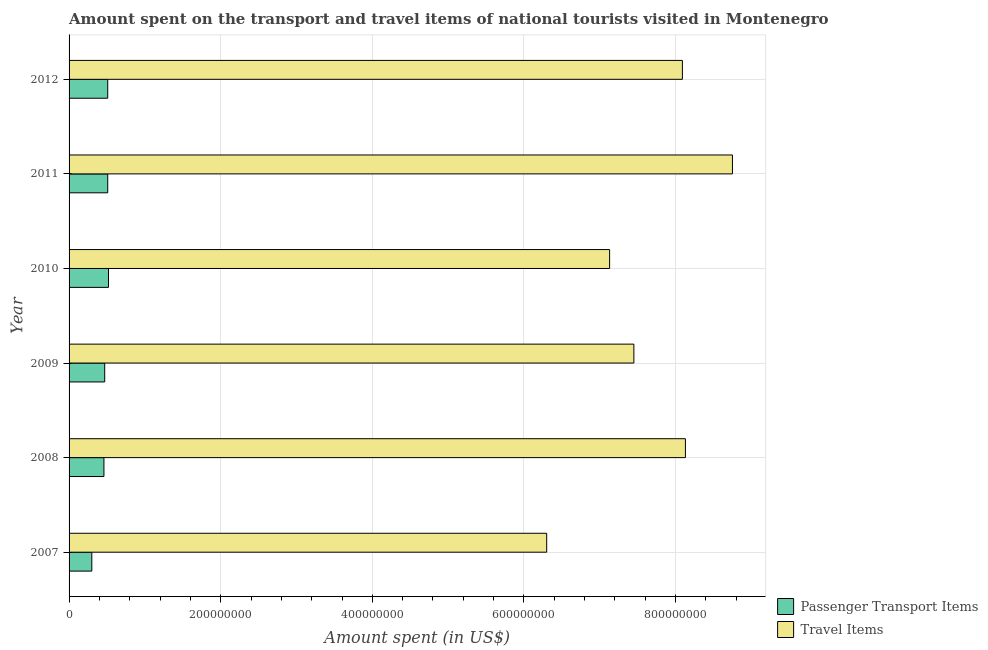How many different coloured bars are there?
Offer a very short reply. 2. How many groups of bars are there?
Keep it short and to the point. 6. What is the label of the 2nd group of bars from the top?
Your response must be concise. 2011. What is the amount spent on passenger transport items in 2007?
Offer a very short reply. 3.00e+07. Across all years, what is the maximum amount spent in travel items?
Provide a short and direct response. 8.75e+08. Across all years, what is the minimum amount spent on passenger transport items?
Your answer should be very brief. 3.00e+07. What is the total amount spent in travel items in the graph?
Your response must be concise. 4.58e+09. What is the difference between the amount spent on passenger transport items in 2007 and that in 2010?
Your answer should be compact. -2.20e+07. What is the difference between the amount spent on passenger transport items in 2009 and the amount spent in travel items in 2007?
Provide a succinct answer. -5.83e+08. What is the average amount spent in travel items per year?
Ensure brevity in your answer.  7.64e+08. In the year 2011, what is the difference between the amount spent on passenger transport items and amount spent in travel items?
Keep it short and to the point. -8.24e+08. In how many years, is the amount spent on passenger transport items greater than 760000000 US$?
Keep it short and to the point. 0. What is the ratio of the amount spent in travel items in 2009 to that in 2010?
Ensure brevity in your answer.  1.04. Is the amount spent on passenger transport items in 2007 less than that in 2011?
Make the answer very short. Yes. What is the difference between the highest and the second highest amount spent in travel items?
Offer a terse response. 6.20e+07. What is the difference between the highest and the lowest amount spent on passenger transport items?
Provide a succinct answer. 2.20e+07. Is the sum of the amount spent in travel items in 2008 and 2012 greater than the maximum amount spent on passenger transport items across all years?
Give a very brief answer. Yes. What does the 2nd bar from the top in 2012 represents?
Give a very brief answer. Passenger Transport Items. What does the 1st bar from the bottom in 2008 represents?
Offer a very short reply. Passenger Transport Items. Are all the bars in the graph horizontal?
Provide a succinct answer. Yes. How many years are there in the graph?
Your answer should be very brief. 6. What is the difference between two consecutive major ticks on the X-axis?
Your answer should be compact. 2.00e+08. Are the values on the major ticks of X-axis written in scientific E-notation?
Ensure brevity in your answer.  No. Does the graph contain any zero values?
Make the answer very short. No. Does the graph contain grids?
Offer a very short reply. Yes. Where does the legend appear in the graph?
Your answer should be very brief. Bottom right. How many legend labels are there?
Make the answer very short. 2. How are the legend labels stacked?
Provide a succinct answer. Vertical. What is the title of the graph?
Provide a succinct answer. Amount spent on the transport and travel items of national tourists visited in Montenegro. What is the label or title of the X-axis?
Your response must be concise. Amount spent (in US$). What is the label or title of the Y-axis?
Provide a succinct answer. Year. What is the Amount spent (in US$) in Passenger Transport Items in 2007?
Give a very brief answer. 3.00e+07. What is the Amount spent (in US$) of Travel Items in 2007?
Provide a succinct answer. 6.30e+08. What is the Amount spent (in US$) in Passenger Transport Items in 2008?
Your answer should be compact. 4.60e+07. What is the Amount spent (in US$) in Travel Items in 2008?
Your answer should be very brief. 8.13e+08. What is the Amount spent (in US$) in Passenger Transport Items in 2009?
Keep it short and to the point. 4.70e+07. What is the Amount spent (in US$) of Travel Items in 2009?
Make the answer very short. 7.45e+08. What is the Amount spent (in US$) of Passenger Transport Items in 2010?
Keep it short and to the point. 5.20e+07. What is the Amount spent (in US$) in Travel Items in 2010?
Keep it short and to the point. 7.13e+08. What is the Amount spent (in US$) in Passenger Transport Items in 2011?
Ensure brevity in your answer.  5.10e+07. What is the Amount spent (in US$) in Travel Items in 2011?
Provide a short and direct response. 8.75e+08. What is the Amount spent (in US$) in Passenger Transport Items in 2012?
Provide a short and direct response. 5.10e+07. What is the Amount spent (in US$) of Travel Items in 2012?
Provide a succinct answer. 8.09e+08. Across all years, what is the maximum Amount spent (in US$) in Passenger Transport Items?
Provide a short and direct response. 5.20e+07. Across all years, what is the maximum Amount spent (in US$) in Travel Items?
Provide a short and direct response. 8.75e+08. Across all years, what is the minimum Amount spent (in US$) in Passenger Transport Items?
Your answer should be very brief. 3.00e+07. Across all years, what is the minimum Amount spent (in US$) in Travel Items?
Offer a terse response. 6.30e+08. What is the total Amount spent (in US$) in Passenger Transport Items in the graph?
Offer a terse response. 2.77e+08. What is the total Amount spent (in US$) of Travel Items in the graph?
Make the answer very short. 4.58e+09. What is the difference between the Amount spent (in US$) of Passenger Transport Items in 2007 and that in 2008?
Offer a terse response. -1.60e+07. What is the difference between the Amount spent (in US$) in Travel Items in 2007 and that in 2008?
Provide a short and direct response. -1.83e+08. What is the difference between the Amount spent (in US$) in Passenger Transport Items in 2007 and that in 2009?
Provide a succinct answer. -1.70e+07. What is the difference between the Amount spent (in US$) of Travel Items in 2007 and that in 2009?
Make the answer very short. -1.15e+08. What is the difference between the Amount spent (in US$) in Passenger Transport Items in 2007 and that in 2010?
Ensure brevity in your answer.  -2.20e+07. What is the difference between the Amount spent (in US$) in Travel Items in 2007 and that in 2010?
Offer a very short reply. -8.30e+07. What is the difference between the Amount spent (in US$) in Passenger Transport Items in 2007 and that in 2011?
Make the answer very short. -2.10e+07. What is the difference between the Amount spent (in US$) in Travel Items in 2007 and that in 2011?
Ensure brevity in your answer.  -2.45e+08. What is the difference between the Amount spent (in US$) in Passenger Transport Items in 2007 and that in 2012?
Give a very brief answer. -2.10e+07. What is the difference between the Amount spent (in US$) of Travel Items in 2007 and that in 2012?
Keep it short and to the point. -1.79e+08. What is the difference between the Amount spent (in US$) in Passenger Transport Items in 2008 and that in 2009?
Your answer should be very brief. -1.00e+06. What is the difference between the Amount spent (in US$) of Travel Items in 2008 and that in 2009?
Offer a very short reply. 6.80e+07. What is the difference between the Amount spent (in US$) in Passenger Transport Items in 2008 and that in 2010?
Your answer should be very brief. -6.00e+06. What is the difference between the Amount spent (in US$) of Travel Items in 2008 and that in 2010?
Keep it short and to the point. 1.00e+08. What is the difference between the Amount spent (in US$) of Passenger Transport Items in 2008 and that in 2011?
Ensure brevity in your answer.  -5.00e+06. What is the difference between the Amount spent (in US$) in Travel Items in 2008 and that in 2011?
Make the answer very short. -6.20e+07. What is the difference between the Amount spent (in US$) of Passenger Transport Items in 2008 and that in 2012?
Provide a succinct answer. -5.00e+06. What is the difference between the Amount spent (in US$) in Passenger Transport Items in 2009 and that in 2010?
Offer a terse response. -5.00e+06. What is the difference between the Amount spent (in US$) of Travel Items in 2009 and that in 2010?
Offer a very short reply. 3.20e+07. What is the difference between the Amount spent (in US$) of Passenger Transport Items in 2009 and that in 2011?
Offer a very short reply. -4.00e+06. What is the difference between the Amount spent (in US$) in Travel Items in 2009 and that in 2011?
Your answer should be compact. -1.30e+08. What is the difference between the Amount spent (in US$) in Travel Items in 2009 and that in 2012?
Give a very brief answer. -6.40e+07. What is the difference between the Amount spent (in US$) in Passenger Transport Items in 2010 and that in 2011?
Offer a very short reply. 1.00e+06. What is the difference between the Amount spent (in US$) in Travel Items in 2010 and that in 2011?
Make the answer very short. -1.62e+08. What is the difference between the Amount spent (in US$) in Passenger Transport Items in 2010 and that in 2012?
Your answer should be compact. 1.00e+06. What is the difference between the Amount spent (in US$) in Travel Items in 2010 and that in 2012?
Provide a short and direct response. -9.60e+07. What is the difference between the Amount spent (in US$) of Travel Items in 2011 and that in 2012?
Offer a very short reply. 6.60e+07. What is the difference between the Amount spent (in US$) in Passenger Transport Items in 2007 and the Amount spent (in US$) in Travel Items in 2008?
Make the answer very short. -7.83e+08. What is the difference between the Amount spent (in US$) in Passenger Transport Items in 2007 and the Amount spent (in US$) in Travel Items in 2009?
Keep it short and to the point. -7.15e+08. What is the difference between the Amount spent (in US$) of Passenger Transport Items in 2007 and the Amount spent (in US$) of Travel Items in 2010?
Offer a terse response. -6.83e+08. What is the difference between the Amount spent (in US$) in Passenger Transport Items in 2007 and the Amount spent (in US$) in Travel Items in 2011?
Provide a succinct answer. -8.45e+08. What is the difference between the Amount spent (in US$) of Passenger Transport Items in 2007 and the Amount spent (in US$) of Travel Items in 2012?
Offer a terse response. -7.79e+08. What is the difference between the Amount spent (in US$) of Passenger Transport Items in 2008 and the Amount spent (in US$) of Travel Items in 2009?
Provide a succinct answer. -6.99e+08. What is the difference between the Amount spent (in US$) of Passenger Transport Items in 2008 and the Amount spent (in US$) of Travel Items in 2010?
Give a very brief answer. -6.67e+08. What is the difference between the Amount spent (in US$) of Passenger Transport Items in 2008 and the Amount spent (in US$) of Travel Items in 2011?
Keep it short and to the point. -8.29e+08. What is the difference between the Amount spent (in US$) in Passenger Transport Items in 2008 and the Amount spent (in US$) in Travel Items in 2012?
Your response must be concise. -7.63e+08. What is the difference between the Amount spent (in US$) in Passenger Transport Items in 2009 and the Amount spent (in US$) in Travel Items in 2010?
Your response must be concise. -6.66e+08. What is the difference between the Amount spent (in US$) in Passenger Transport Items in 2009 and the Amount spent (in US$) in Travel Items in 2011?
Offer a very short reply. -8.28e+08. What is the difference between the Amount spent (in US$) in Passenger Transport Items in 2009 and the Amount spent (in US$) in Travel Items in 2012?
Offer a very short reply. -7.62e+08. What is the difference between the Amount spent (in US$) of Passenger Transport Items in 2010 and the Amount spent (in US$) of Travel Items in 2011?
Your answer should be compact. -8.23e+08. What is the difference between the Amount spent (in US$) in Passenger Transport Items in 2010 and the Amount spent (in US$) in Travel Items in 2012?
Your response must be concise. -7.57e+08. What is the difference between the Amount spent (in US$) of Passenger Transport Items in 2011 and the Amount spent (in US$) of Travel Items in 2012?
Your answer should be compact. -7.58e+08. What is the average Amount spent (in US$) in Passenger Transport Items per year?
Offer a terse response. 4.62e+07. What is the average Amount spent (in US$) of Travel Items per year?
Your response must be concise. 7.64e+08. In the year 2007, what is the difference between the Amount spent (in US$) of Passenger Transport Items and Amount spent (in US$) of Travel Items?
Offer a terse response. -6.00e+08. In the year 2008, what is the difference between the Amount spent (in US$) in Passenger Transport Items and Amount spent (in US$) in Travel Items?
Provide a short and direct response. -7.67e+08. In the year 2009, what is the difference between the Amount spent (in US$) of Passenger Transport Items and Amount spent (in US$) of Travel Items?
Your response must be concise. -6.98e+08. In the year 2010, what is the difference between the Amount spent (in US$) in Passenger Transport Items and Amount spent (in US$) in Travel Items?
Your answer should be compact. -6.61e+08. In the year 2011, what is the difference between the Amount spent (in US$) in Passenger Transport Items and Amount spent (in US$) in Travel Items?
Your response must be concise. -8.24e+08. In the year 2012, what is the difference between the Amount spent (in US$) in Passenger Transport Items and Amount spent (in US$) in Travel Items?
Keep it short and to the point. -7.58e+08. What is the ratio of the Amount spent (in US$) of Passenger Transport Items in 2007 to that in 2008?
Keep it short and to the point. 0.65. What is the ratio of the Amount spent (in US$) of Travel Items in 2007 to that in 2008?
Your response must be concise. 0.77. What is the ratio of the Amount spent (in US$) in Passenger Transport Items in 2007 to that in 2009?
Your answer should be very brief. 0.64. What is the ratio of the Amount spent (in US$) of Travel Items in 2007 to that in 2009?
Provide a succinct answer. 0.85. What is the ratio of the Amount spent (in US$) in Passenger Transport Items in 2007 to that in 2010?
Your response must be concise. 0.58. What is the ratio of the Amount spent (in US$) of Travel Items in 2007 to that in 2010?
Keep it short and to the point. 0.88. What is the ratio of the Amount spent (in US$) of Passenger Transport Items in 2007 to that in 2011?
Offer a very short reply. 0.59. What is the ratio of the Amount spent (in US$) of Travel Items in 2007 to that in 2011?
Provide a succinct answer. 0.72. What is the ratio of the Amount spent (in US$) of Passenger Transport Items in 2007 to that in 2012?
Your answer should be compact. 0.59. What is the ratio of the Amount spent (in US$) in Travel Items in 2007 to that in 2012?
Keep it short and to the point. 0.78. What is the ratio of the Amount spent (in US$) of Passenger Transport Items in 2008 to that in 2009?
Offer a terse response. 0.98. What is the ratio of the Amount spent (in US$) of Travel Items in 2008 to that in 2009?
Ensure brevity in your answer.  1.09. What is the ratio of the Amount spent (in US$) of Passenger Transport Items in 2008 to that in 2010?
Your answer should be very brief. 0.88. What is the ratio of the Amount spent (in US$) in Travel Items in 2008 to that in 2010?
Make the answer very short. 1.14. What is the ratio of the Amount spent (in US$) in Passenger Transport Items in 2008 to that in 2011?
Your answer should be very brief. 0.9. What is the ratio of the Amount spent (in US$) in Travel Items in 2008 to that in 2011?
Keep it short and to the point. 0.93. What is the ratio of the Amount spent (in US$) in Passenger Transport Items in 2008 to that in 2012?
Keep it short and to the point. 0.9. What is the ratio of the Amount spent (in US$) of Passenger Transport Items in 2009 to that in 2010?
Offer a terse response. 0.9. What is the ratio of the Amount spent (in US$) in Travel Items in 2009 to that in 2010?
Give a very brief answer. 1.04. What is the ratio of the Amount spent (in US$) of Passenger Transport Items in 2009 to that in 2011?
Your response must be concise. 0.92. What is the ratio of the Amount spent (in US$) of Travel Items in 2009 to that in 2011?
Offer a terse response. 0.85. What is the ratio of the Amount spent (in US$) of Passenger Transport Items in 2009 to that in 2012?
Your response must be concise. 0.92. What is the ratio of the Amount spent (in US$) in Travel Items in 2009 to that in 2012?
Make the answer very short. 0.92. What is the ratio of the Amount spent (in US$) of Passenger Transport Items in 2010 to that in 2011?
Keep it short and to the point. 1.02. What is the ratio of the Amount spent (in US$) in Travel Items in 2010 to that in 2011?
Your response must be concise. 0.81. What is the ratio of the Amount spent (in US$) of Passenger Transport Items in 2010 to that in 2012?
Ensure brevity in your answer.  1.02. What is the ratio of the Amount spent (in US$) in Travel Items in 2010 to that in 2012?
Provide a succinct answer. 0.88. What is the ratio of the Amount spent (in US$) of Travel Items in 2011 to that in 2012?
Make the answer very short. 1.08. What is the difference between the highest and the second highest Amount spent (in US$) in Passenger Transport Items?
Your response must be concise. 1.00e+06. What is the difference between the highest and the second highest Amount spent (in US$) of Travel Items?
Your response must be concise. 6.20e+07. What is the difference between the highest and the lowest Amount spent (in US$) in Passenger Transport Items?
Make the answer very short. 2.20e+07. What is the difference between the highest and the lowest Amount spent (in US$) of Travel Items?
Your answer should be compact. 2.45e+08. 